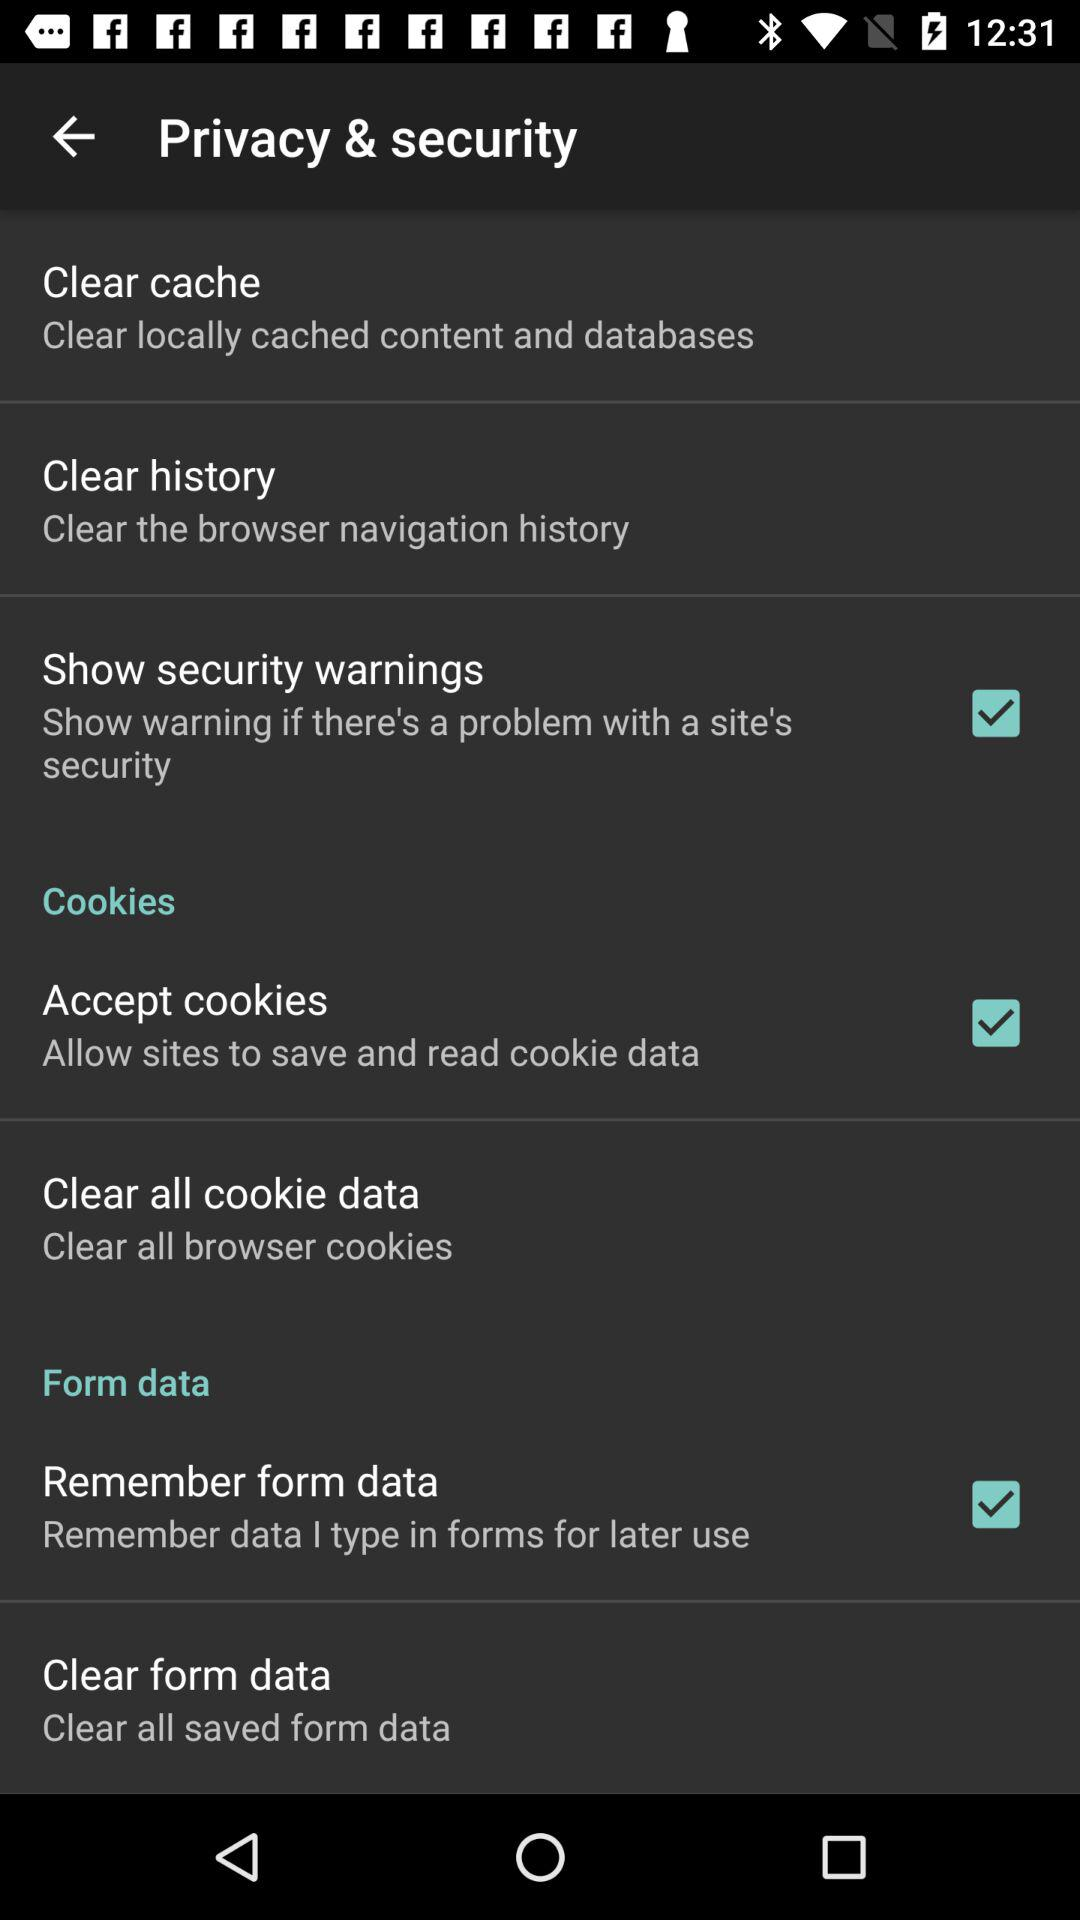What is the status of "Remember form data"? The status is "on". 